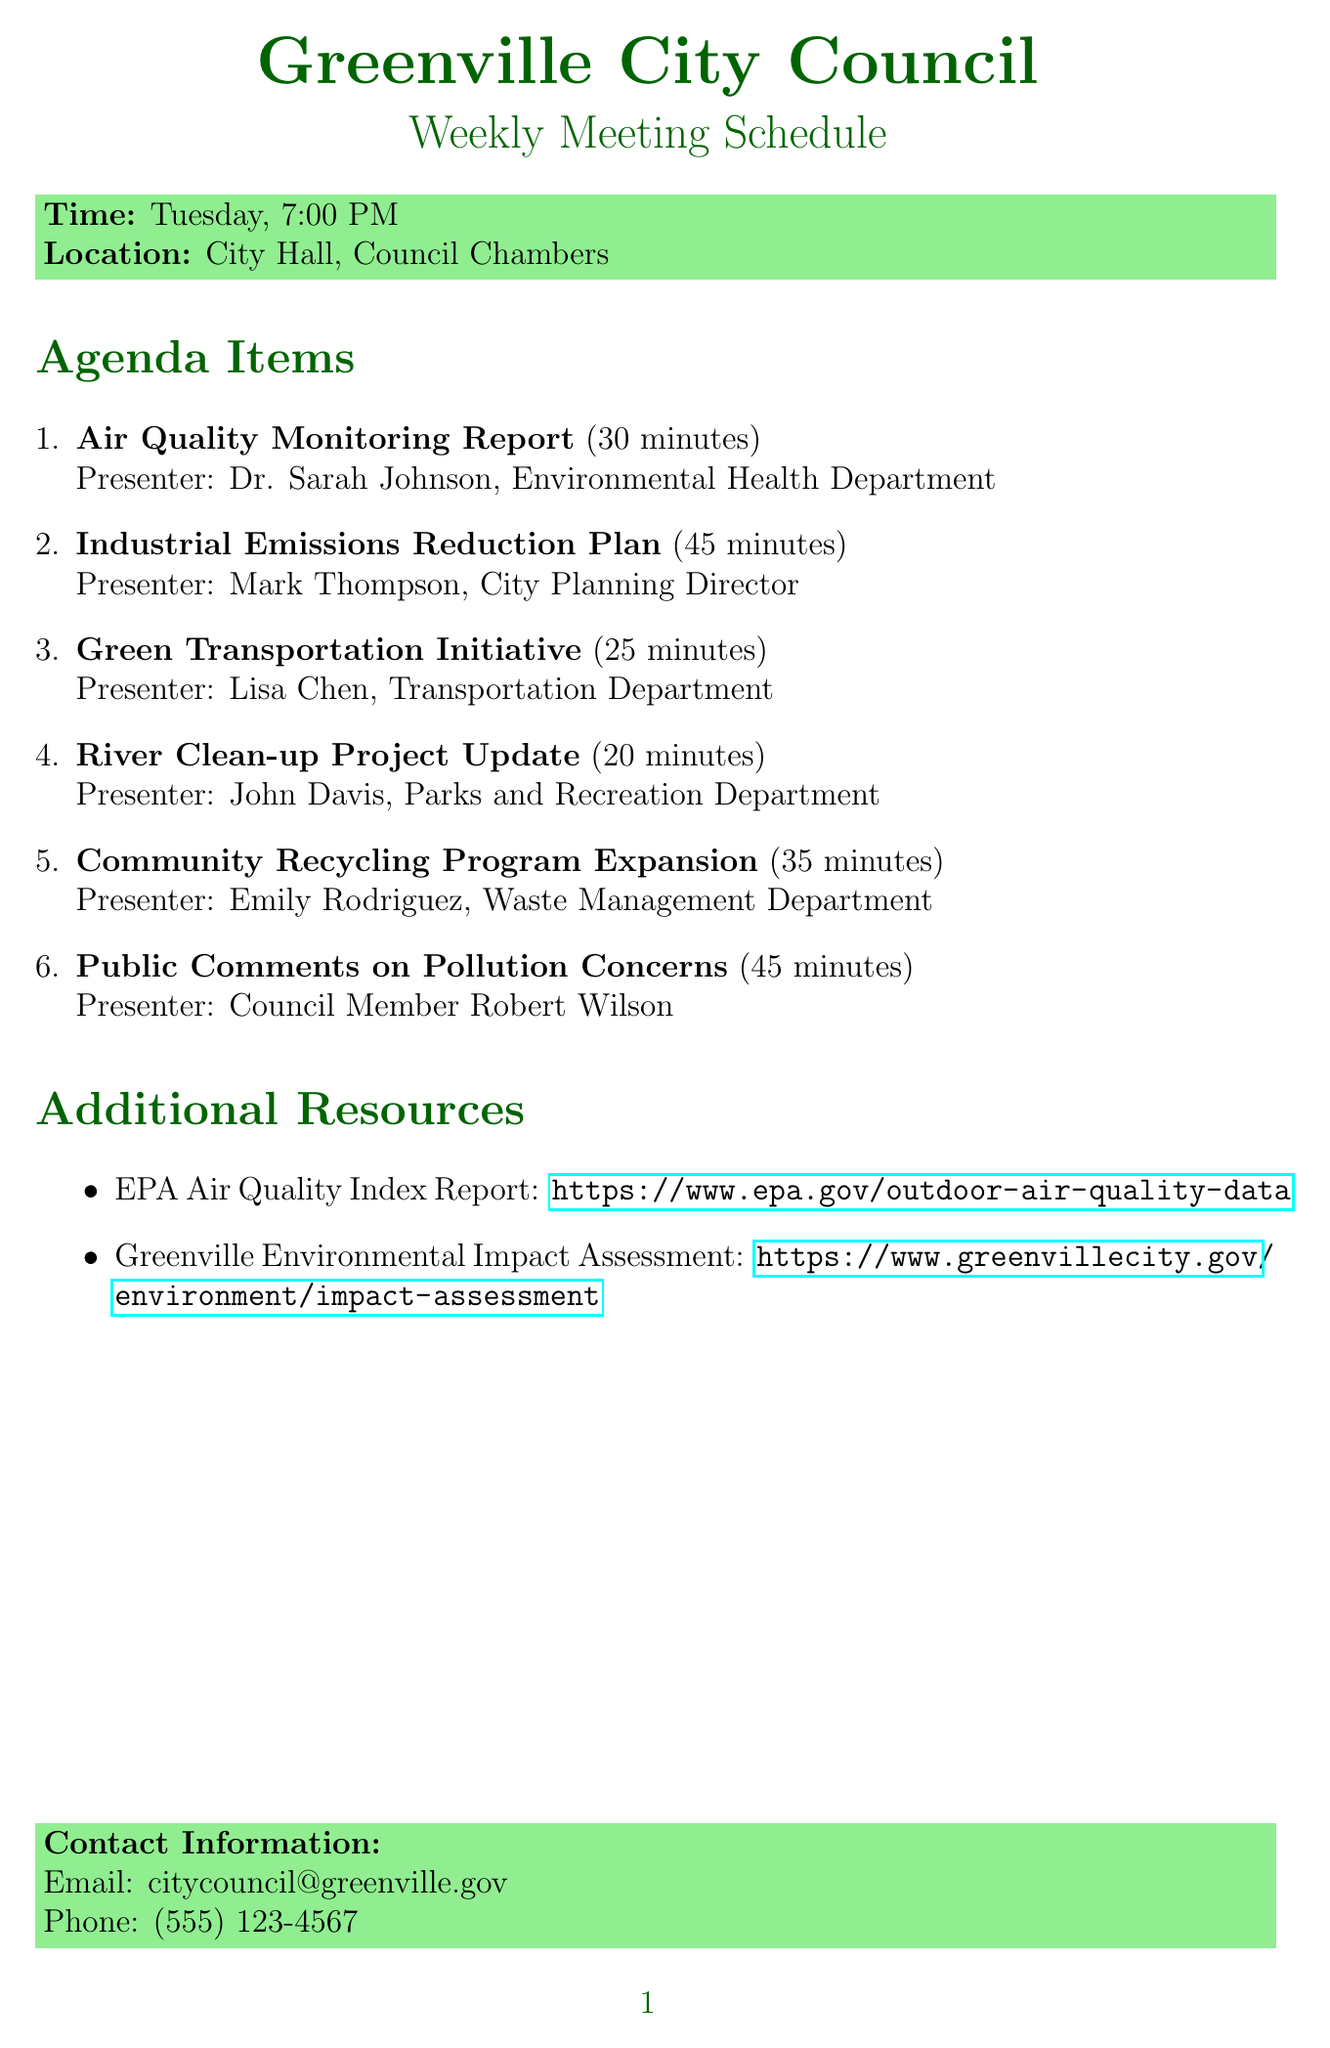What day is the council meeting held? The document specifies that the council meeting takes place on Tuesday each week.
Answer: Tuesday Who presents the Air Quality Monitoring Report? The presenter for the Air Quality Monitoring Report is mentioned as Dr. Sarah Johnson from the Environmental Health Department.
Answer: Dr. Sarah Johnson What is the duration of the Industrial Emissions Reduction Plan item? The document lists the duration of the Industrial Emissions Reduction Plan agenda item as 45 minutes.
Answer: 45 minutes How many minutes is allocated for the Public Comments on Pollution Concerns? The duration for the Public Comments on Pollution Concerns is explicitly stated to be 45 minutes in the document.
Answer: 45 minutes What is the title of the last agenda item? The last agenda item is detailed as Public Comments on Pollution Concerns.
Answer: Public Comments on Pollution Concerns What department does Emily Rodriguez represent? The document indicates that Emily Rodriguez is from the Waste Management Department.
Answer: Waste Management Department What type of initiative is Lisa Chen presenting? The agenda item presented by Lisa Chen is described as a Green Transportation Initiative.
Answer: Green Transportation Initiative What is the location of the council meeting? The document clearly states that the meeting takes place at City Hall, Council Chambers.
Answer: City Hall, Council Chambers What additional resource can provide information on air quality? The document lists the EPA Air Quality Index Report as an additional resource for air quality information.
Answer: EPA Air Quality Index Report 